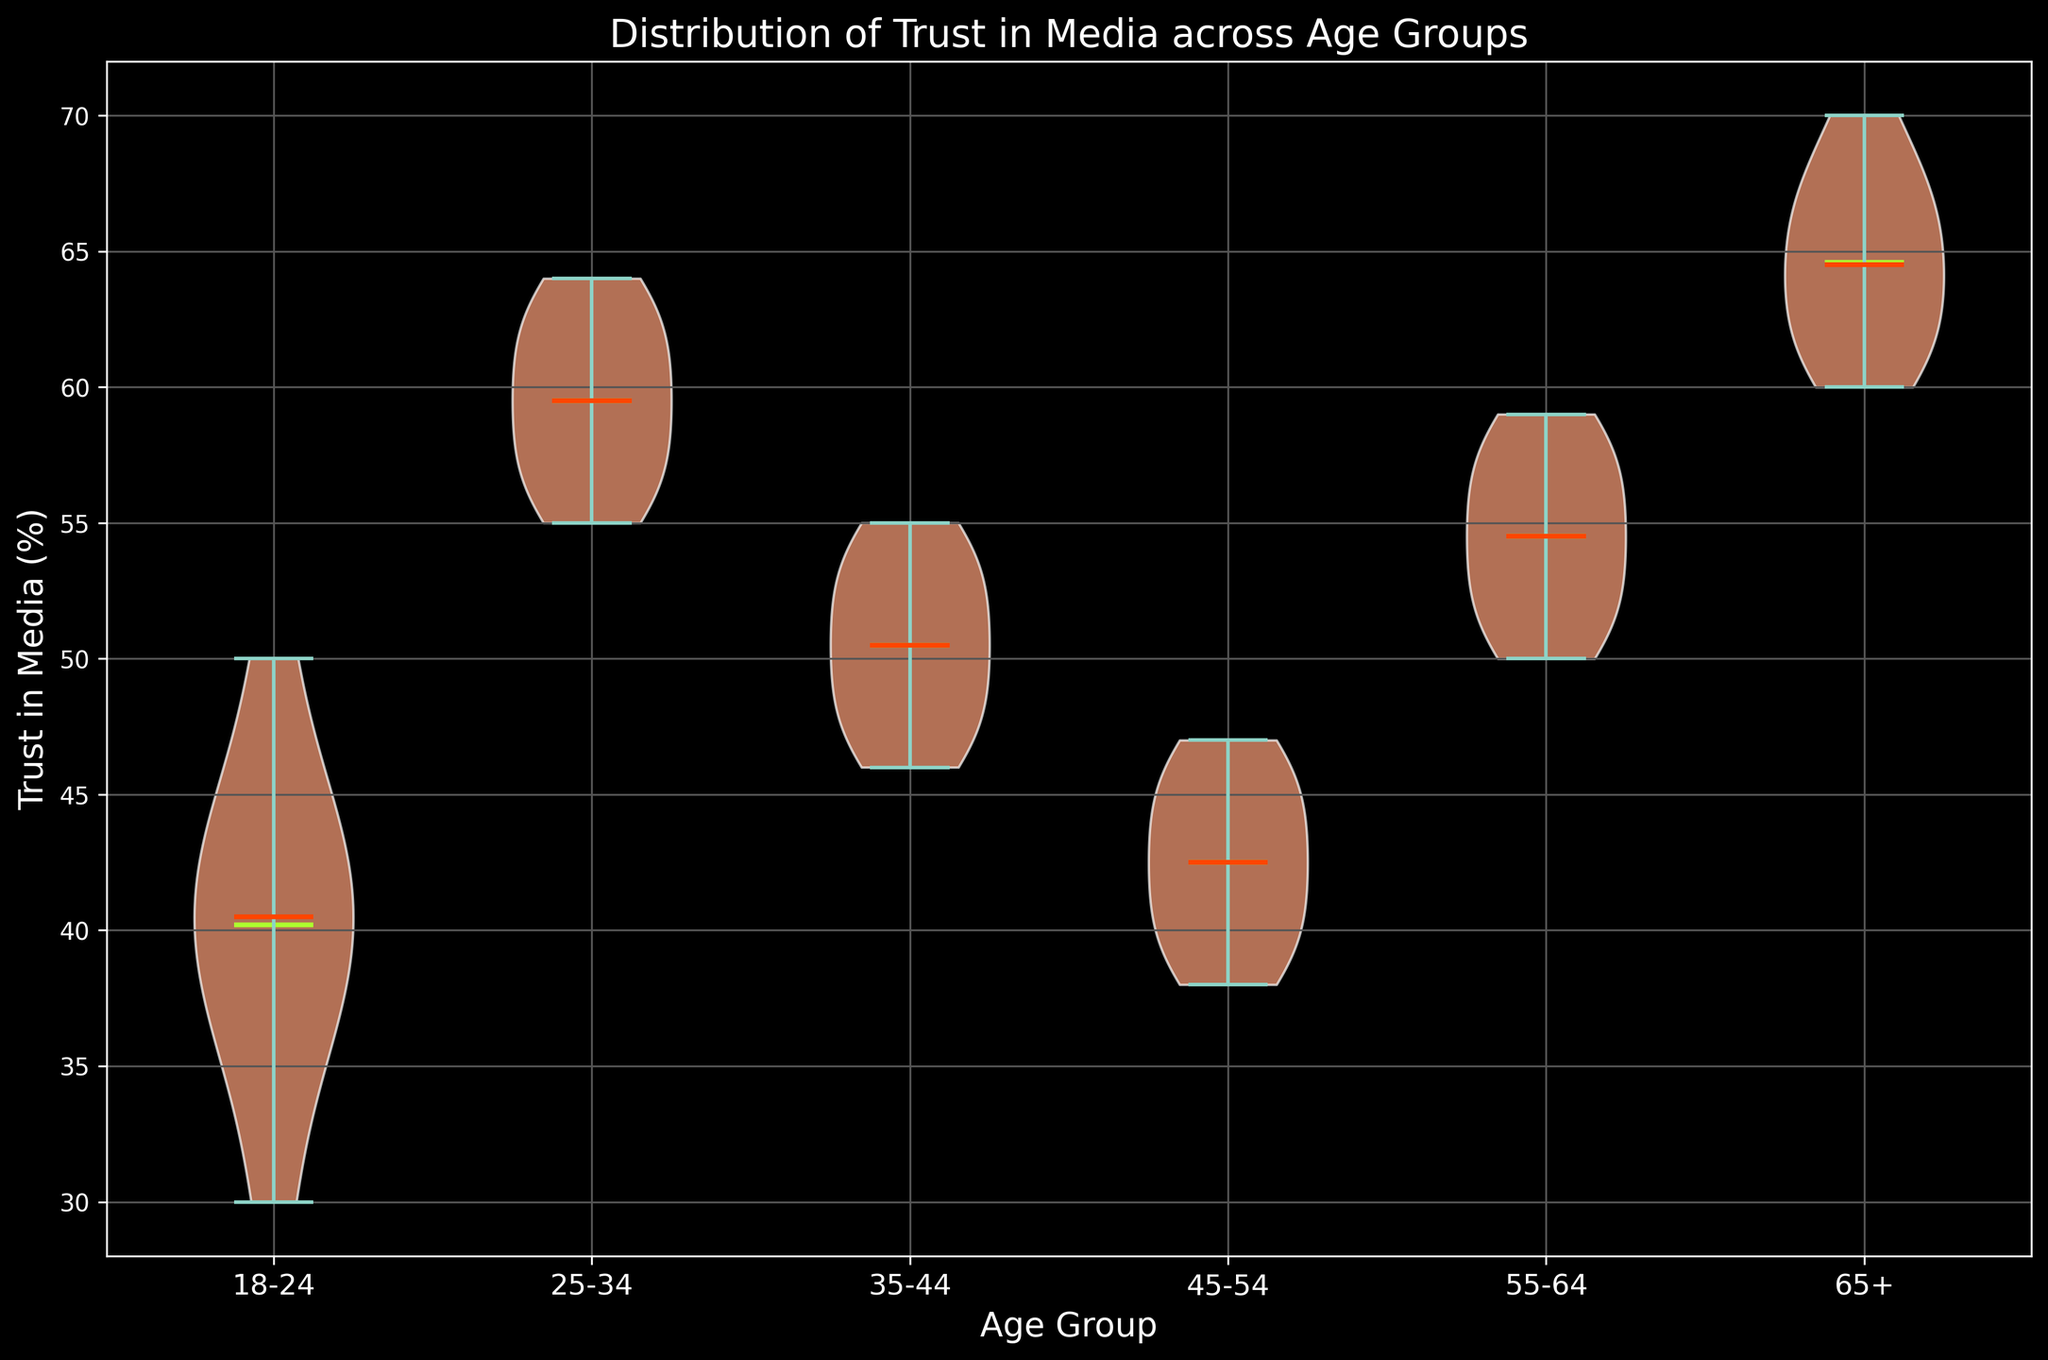Which age group has the highest median trust in media? The median is indicated by the orange-red line in the middle of each violin plot. The age group 65+ has the highest median trust level in the media.
Answer: 65+ How does the mean trust in media for age group 25-34 compare to age group 45-54? The mean is indicated by the green-yellow line in each violin plot. The mean trust in media is higher for the 25-34 age group compared to the 45-54 age group.
Answer: Higher What is the range of trust in media for the age group 55-64? Look at the spread of the violin plot for the 55-64 age group. The minimum value is 50, and the maximum value is 59, so the range is 59 - 50.
Answer: 9 Which age group has the narrowest distribution of trust in media? This can be inferred by the width of each violin plot. A narrower plot indicates a smaller variance in trust levels. The age group 65+ has the narrowest distribution.
Answer: 65+ Compare the distribution shape of trust in media for age groups 18-24 and 35-44. The 18-24 age group has a wider spread, indicating higher variability, whereas the 35-44 age group has a more symmetric and narrower distribution.
Answer: 18-24 has higher variability, 35-44 is more symmetric Which age group has the smallest difference between its median and mean trust in media? Examine the orange-red and green-yellow lines within each violin plot. The distance between these lines is smallest in the 55-64 age group.
Answer: 55-64 Identify the age group with the most outliers in trust in media. Outliers will be visible as small points far from the dense areas of the violin plot. The 18-24 age group shows the most outliers.
Answer: 18-24 Is there any age group where the median trust in media is below the mean trust in media? Compare the position of the orange-red (median) and green-yellow (mean) lines. In the age group 18-24, the median (orange-red line) is below the mean (green-yellow line).
Answer: 18-24 What is the most likely age group to have a trust level in media close to 70? Look at the endpoint of the violin plots. The age group 65+ has trust levels reaching up to 70, making it the most likely group for this trust level.
Answer: 65+ How does the variability in trust in media for the age group 45-54 compare to that of 55-64? The width of the 45-54 violin plot is wider than that of 55-64, indicating higher variability in trust levels.
Answer: Higher variability 